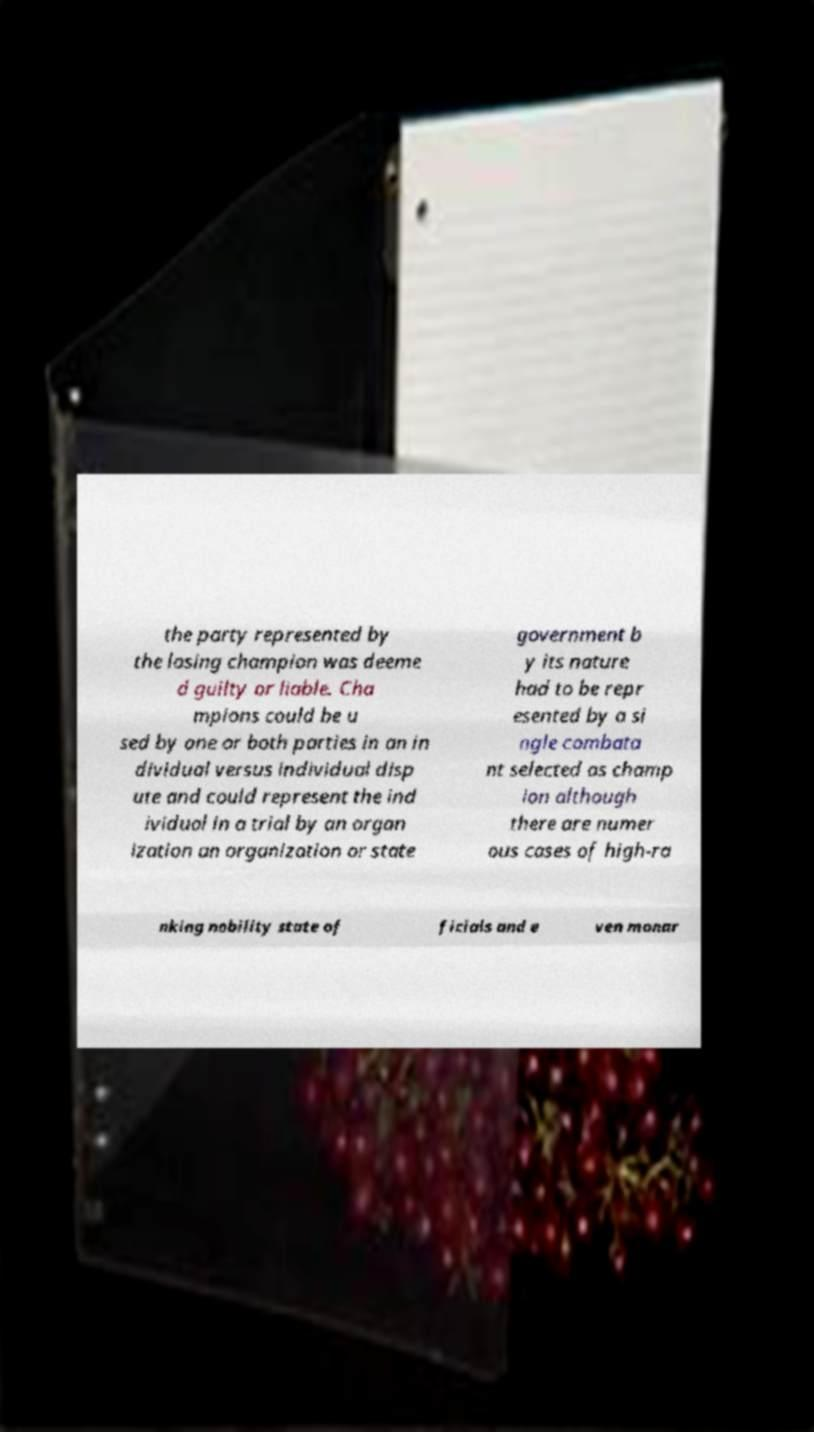Can you accurately transcribe the text from the provided image for me? the party represented by the losing champion was deeme d guilty or liable. Cha mpions could be u sed by one or both parties in an in dividual versus individual disp ute and could represent the ind ividual in a trial by an organ ization an organization or state government b y its nature had to be repr esented by a si ngle combata nt selected as champ ion although there are numer ous cases of high-ra nking nobility state of ficials and e ven monar 